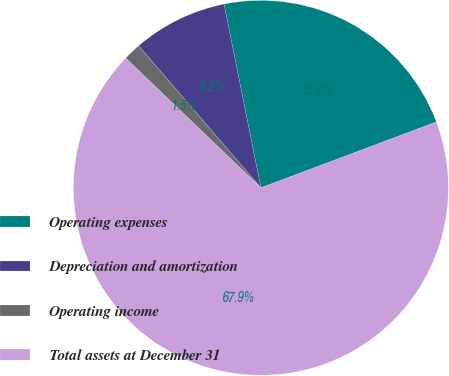Convert chart. <chart><loc_0><loc_0><loc_500><loc_500><pie_chart><fcel>Operating expenses<fcel>Depreciation and amortization<fcel>Operating income<fcel>Total assets at December 31<nl><fcel>22.44%<fcel>8.16%<fcel>1.52%<fcel>67.89%<nl></chart> 